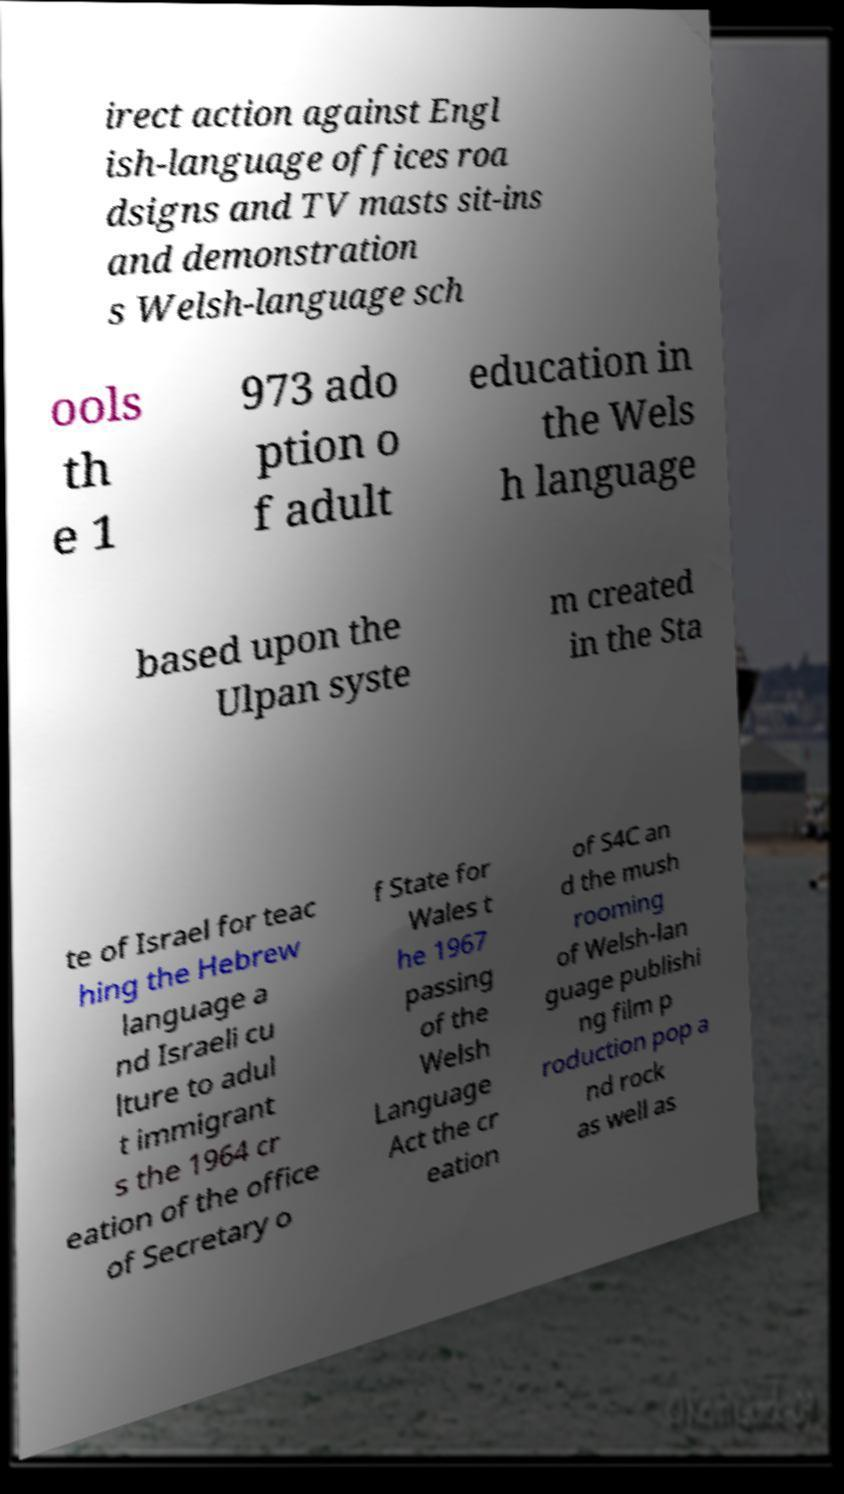There's text embedded in this image that I need extracted. Can you transcribe it verbatim? irect action against Engl ish-language offices roa dsigns and TV masts sit-ins and demonstration s Welsh-language sch ools th e 1 973 ado ption o f adult education in the Wels h language based upon the Ulpan syste m created in the Sta te of Israel for teac hing the Hebrew language a nd Israeli cu lture to adul t immigrant s the 1964 cr eation of the office of Secretary o f State for Wales t he 1967 passing of the Welsh Language Act the cr eation of S4C an d the mush rooming of Welsh-lan guage publishi ng film p roduction pop a nd rock as well as 